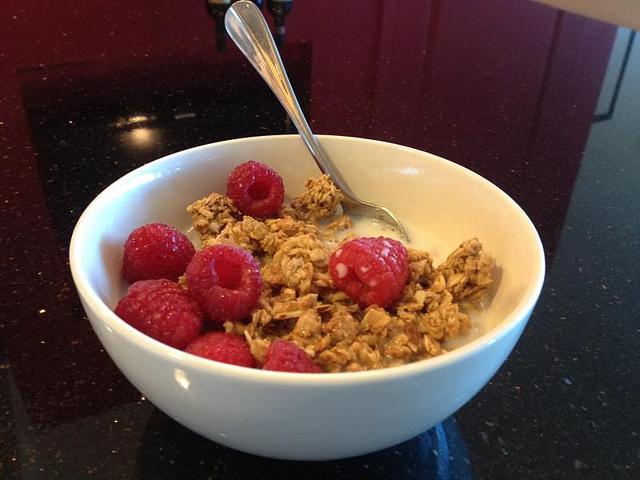Is this breakfast cereal?
Keep it brief. Yes. Is the spoon fully submerged?
Be succinct. No. What kind of fruit is in the bowl?
Quick response, please. Raspberries. 